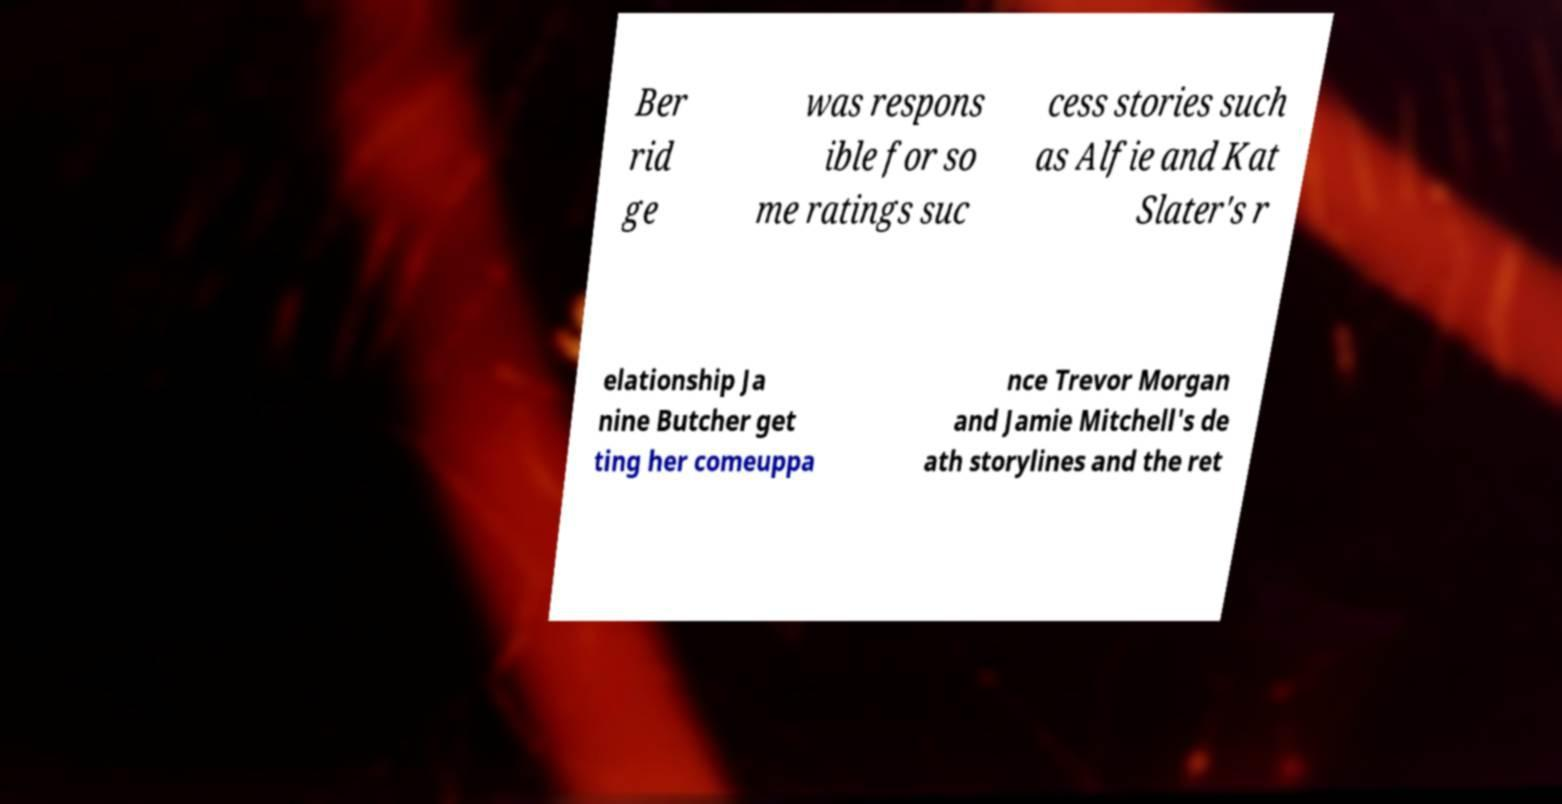For documentation purposes, I need the text within this image transcribed. Could you provide that? Ber rid ge was respons ible for so me ratings suc cess stories such as Alfie and Kat Slater's r elationship Ja nine Butcher get ting her comeuppa nce Trevor Morgan and Jamie Mitchell's de ath storylines and the ret 